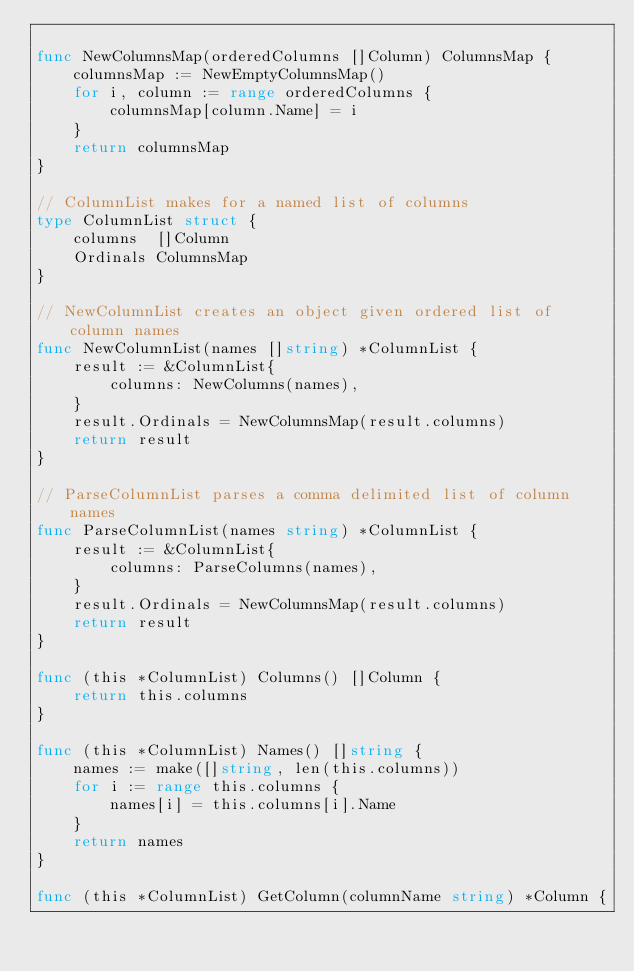Convert code to text. <code><loc_0><loc_0><loc_500><loc_500><_Go_>
func NewColumnsMap(orderedColumns []Column) ColumnsMap {
	columnsMap := NewEmptyColumnsMap()
	for i, column := range orderedColumns {
		columnsMap[column.Name] = i
	}
	return columnsMap
}

// ColumnList makes for a named list of columns
type ColumnList struct {
	columns  []Column
	Ordinals ColumnsMap
}

// NewColumnList creates an object given ordered list of column names
func NewColumnList(names []string) *ColumnList {
	result := &ColumnList{
		columns: NewColumns(names),
	}
	result.Ordinals = NewColumnsMap(result.columns)
	return result
}

// ParseColumnList parses a comma delimited list of column names
func ParseColumnList(names string) *ColumnList {
	result := &ColumnList{
		columns: ParseColumns(names),
	}
	result.Ordinals = NewColumnsMap(result.columns)
	return result
}

func (this *ColumnList) Columns() []Column {
	return this.columns
}

func (this *ColumnList) Names() []string {
	names := make([]string, len(this.columns))
	for i := range this.columns {
		names[i] = this.columns[i].Name
	}
	return names
}

func (this *ColumnList) GetColumn(columnName string) *Column {</code> 